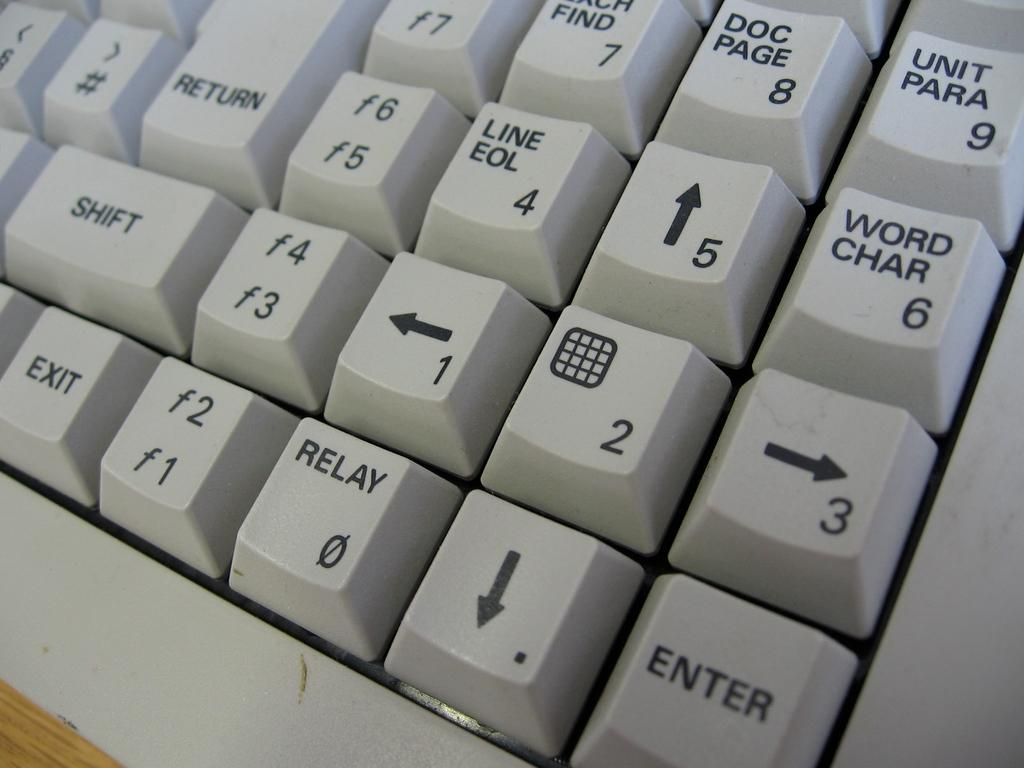Provide a one-sentence caption for the provided image. A white keyboard with a button that says Return at the top and Shift underneath it. it. 